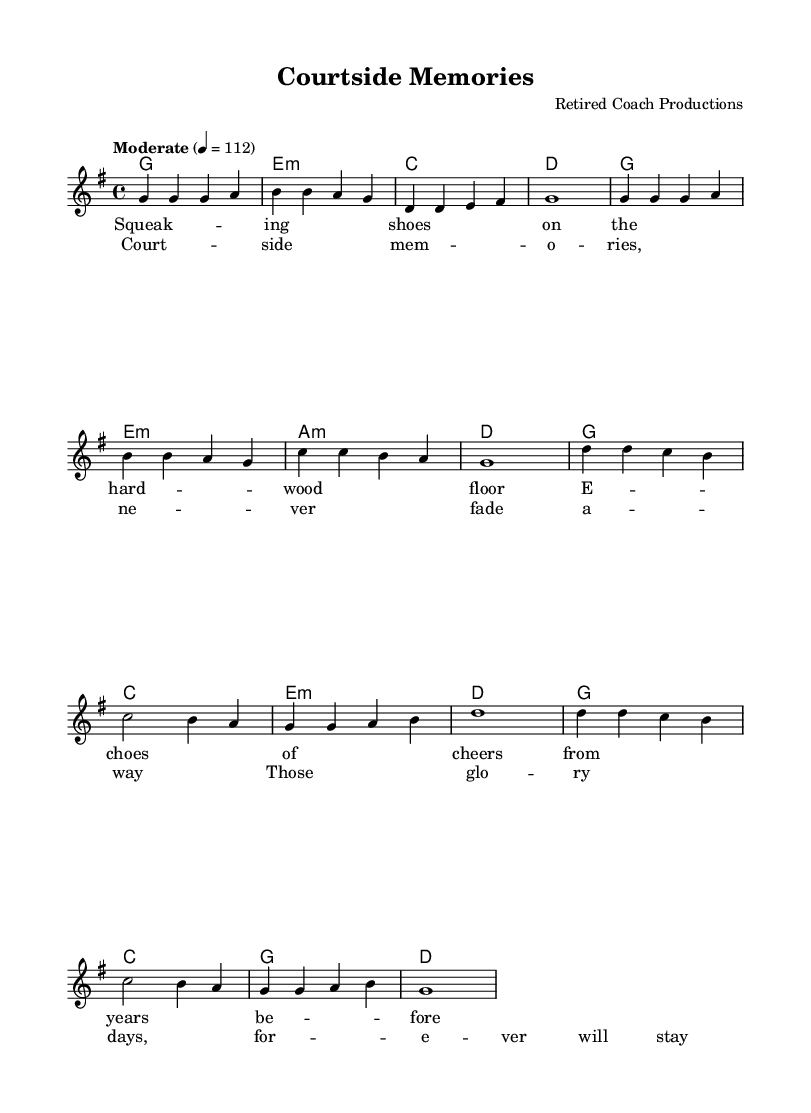What is the key signature of this music? The key signature indicates G major, which has one sharp (F#). This can be determined by looking at the key signature indicated at the beginning of the score, which shows a single sharp.
Answer: G major What is the time signature of this music? The time signature shown at the start of the score is 4/4. This can be identified by the notation next to the clef at the beginning of the piece, which tells you that there are four beats in each measure and the quarter note gets one beat.
Answer: 4/4 What is the tempo marking for this piece? The tempo marking indicates "Moderate" with a beats per minute (bpm) of 112. This is indicated in the tempo direction near the beginning of the score, specifying how fast the music should be played.
Answer: Moderate 4 = 112 How many measures are in the verse section? The verse section consists of 8 measures. This can be counted by looking at the melody section where the measures are divided by bar lines, and observing how many complete measures contain notes for the verse.
Answer: 8 What is the final chord in the chorus? The final chord in the chorus is D major. This can be found at the end of the chorus line in the harmonies section, where the chord notation appears after the last note of the melody in that section.
Answer: D What phrases make up the chorus lyrics? The chorus lyrics consist of two main phrases: "Court-side memories, never fade away" and "Those glory days, forever will stay." This can be deduced by looking at the lyric lines beneath the melody and seeing how they are structured and divided into phrases.
Answer: "Court-side memories, never fade away" and "Those glory days, forever will stay." What is the pattern of harmony in the verse? The harmony in the verse follows a G - E minor - C - D pattern. This is observed by analyzing the chord structure written in the harmonies section below the melody and seeing how those chords progress across the measures of the verse.
Answer: G - E minor - C - D 